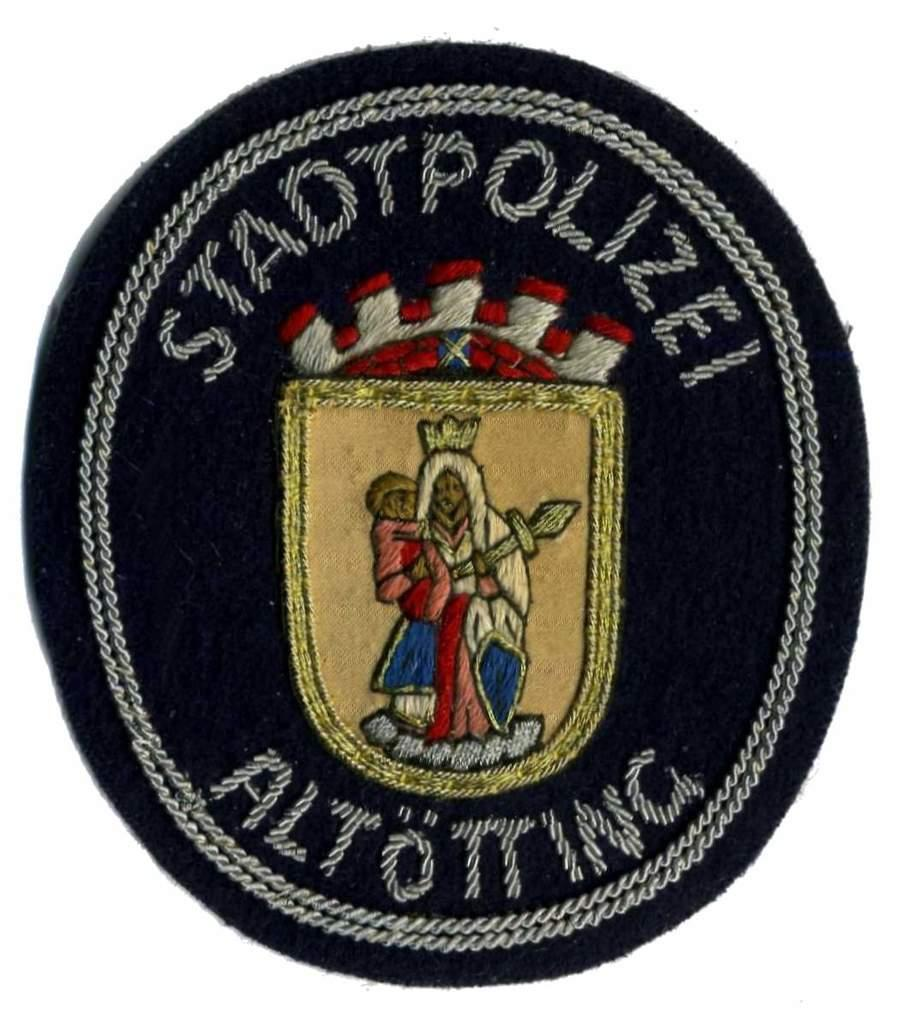What is the main feature of the image? There is a logo in the image. What is depicted in the logo? The logo contains a woman holding a kid. What type of bone can be seen in the image? There is no bone present in the image; it features a logo with a woman holding a kid. What kind of plants are visible in the image? There are no plants visible in the image; it features a logo with a woman holding a kid. 